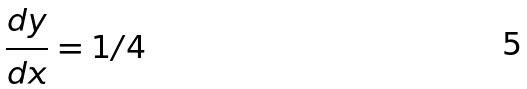Convert formula to latex. <formula><loc_0><loc_0><loc_500><loc_500>\frac { d y } { d x } = 1 / 4</formula> 